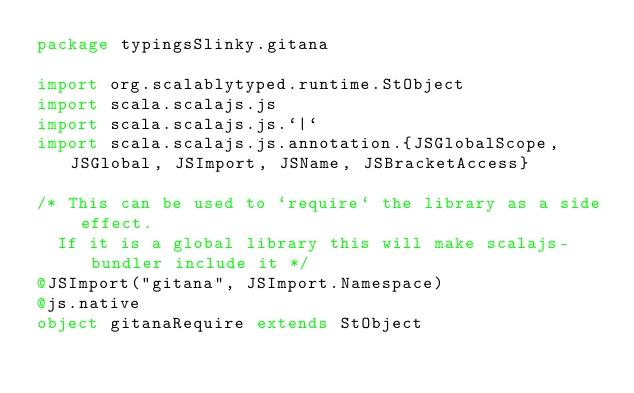<code> <loc_0><loc_0><loc_500><loc_500><_Scala_>package typingsSlinky.gitana

import org.scalablytyped.runtime.StObject
import scala.scalajs.js
import scala.scalajs.js.`|`
import scala.scalajs.js.annotation.{JSGlobalScope, JSGlobal, JSImport, JSName, JSBracketAccess}

/* This can be used to `require` the library as a side effect.
  If it is a global library this will make scalajs-bundler include it */
@JSImport("gitana", JSImport.Namespace)
@js.native
object gitanaRequire extends StObject
</code> 